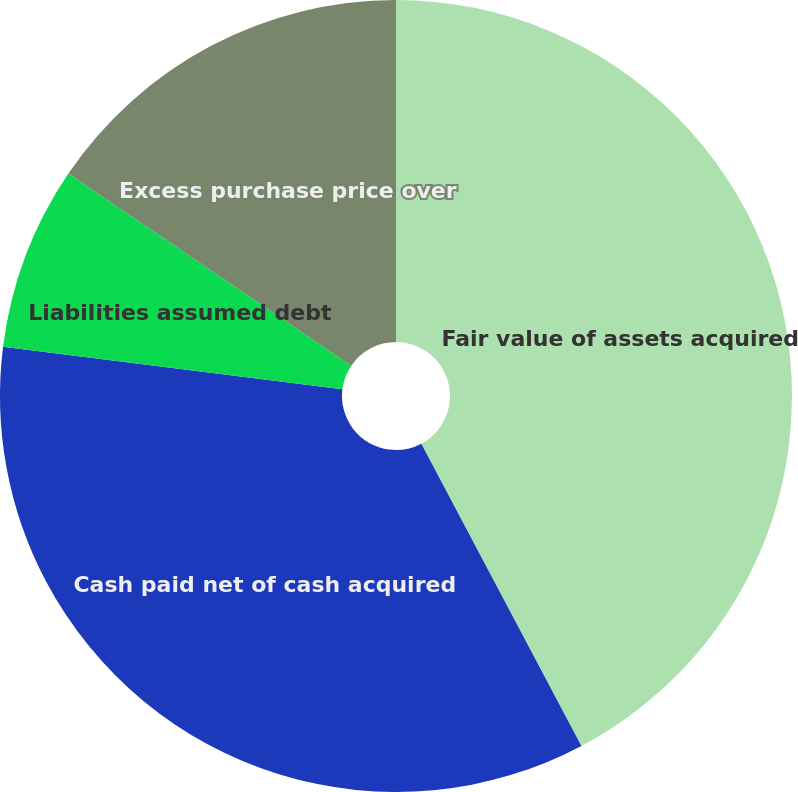Convert chart to OTSL. <chart><loc_0><loc_0><loc_500><loc_500><pie_chart><fcel>Fair value of assets acquired<fcel>Cash paid net of cash acquired<fcel>Liabilities assumed debt<fcel>Excess purchase price over<nl><fcel>42.25%<fcel>34.74%<fcel>7.51%<fcel>15.51%<nl></chart> 